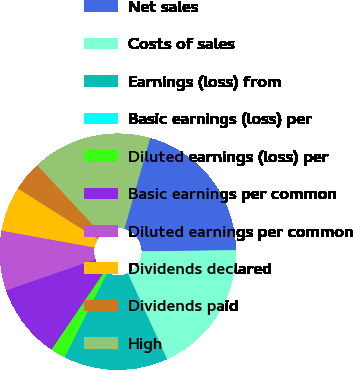Convert chart to OTSL. <chart><loc_0><loc_0><loc_500><loc_500><pie_chart><fcel>Net sales<fcel>Costs of sales<fcel>Earnings (loss) from<fcel>Basic earnings (loss) per<fcel>Diluted earnings (loss) per<fcel>Basic earnings per common<fcel>Diluted earnings per common<fcel>Dividends declared<fcel>Dividends paid<fcel>High<nl><fcel>20.4%<fcel>18.36%<fcel>14.28%<fcel>0.0%<fcel>2.04%<fcel>10.2%<fcel>8.16%<fcel>6.12%<fcel>4.08%<fcel>16.32%<nl></chart> 